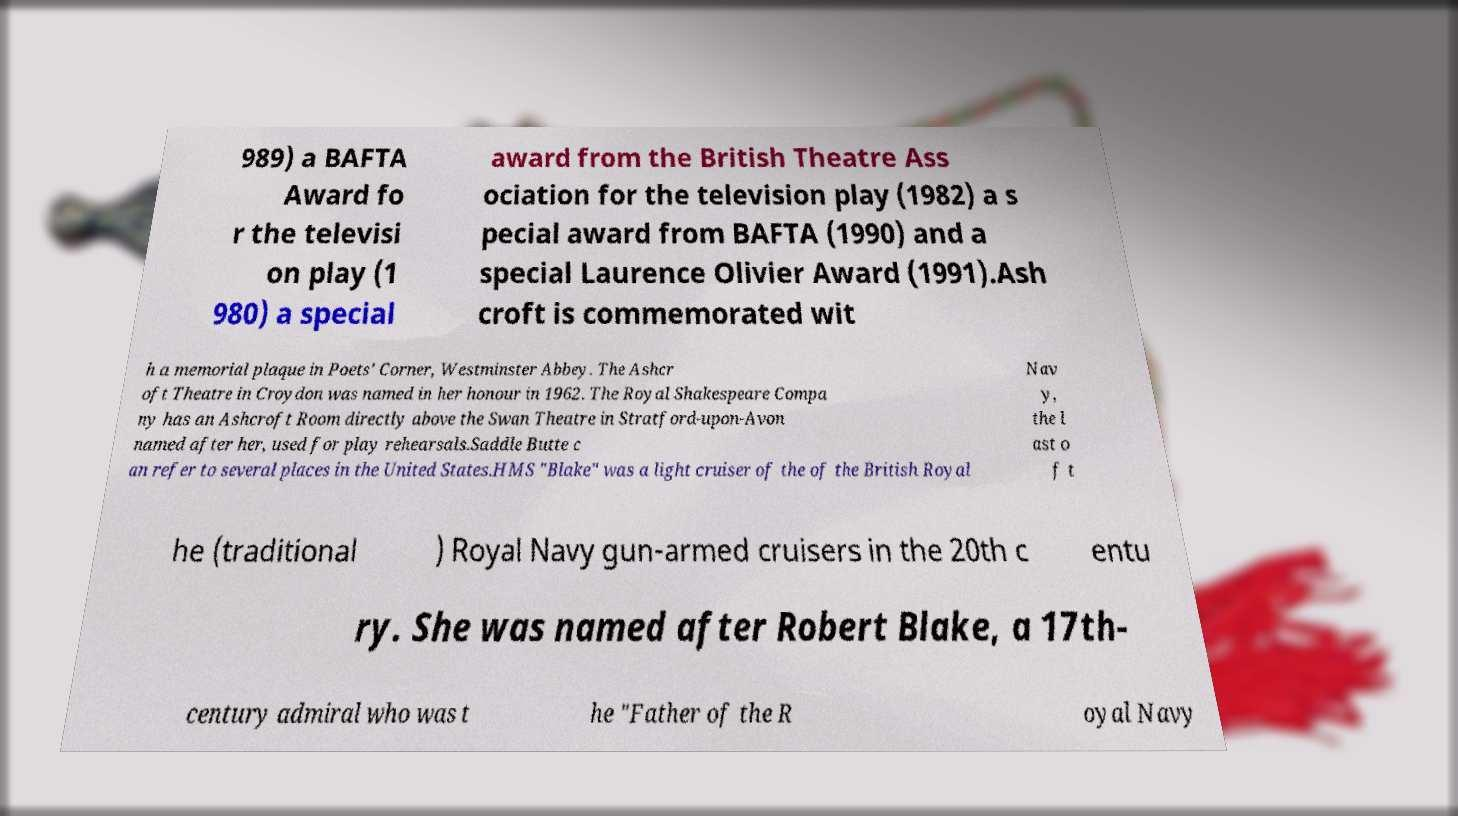Please identify and transcribe the text found in this image. 989) a BAFTA Award fo r the televisi on play (1 980) a special award from the British Theatre Ass ociation for the television play (1982) a s pecial award from BAFTA (1990) and a special Laurence Olivier Award (1991).Ash croft is commemorated wit h a memorial plaque in Poets' Corner, Westminster Abbey. The Ashcr oft Theatre in Croydon was named in her honour in 1962. The Royal Shakespeare Compa ny has an Ashcroft Room directly above the Swan Theatre in Stratford-upon-Avon named after her, used for play rehearsals.Saddle Butte c an refer to several places in the United States.HMS "Blake" was a light cruiser of the of the British Royal Nav y, the l ast o f t he (traditional ) Royal Navy gun-armed cruisers in the 20th c entu ry. She was named after Robert Blake, a 17th- century admiral who was t he "Father of the R oyal Navy 